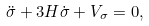Convert formula to latex. <formula><loc_0><loc_0><loc_500><loc_500>\ddot { \sigma } + 3 H \dot { \sigma } + V _ { \sigma } = 0 ,</formula> 